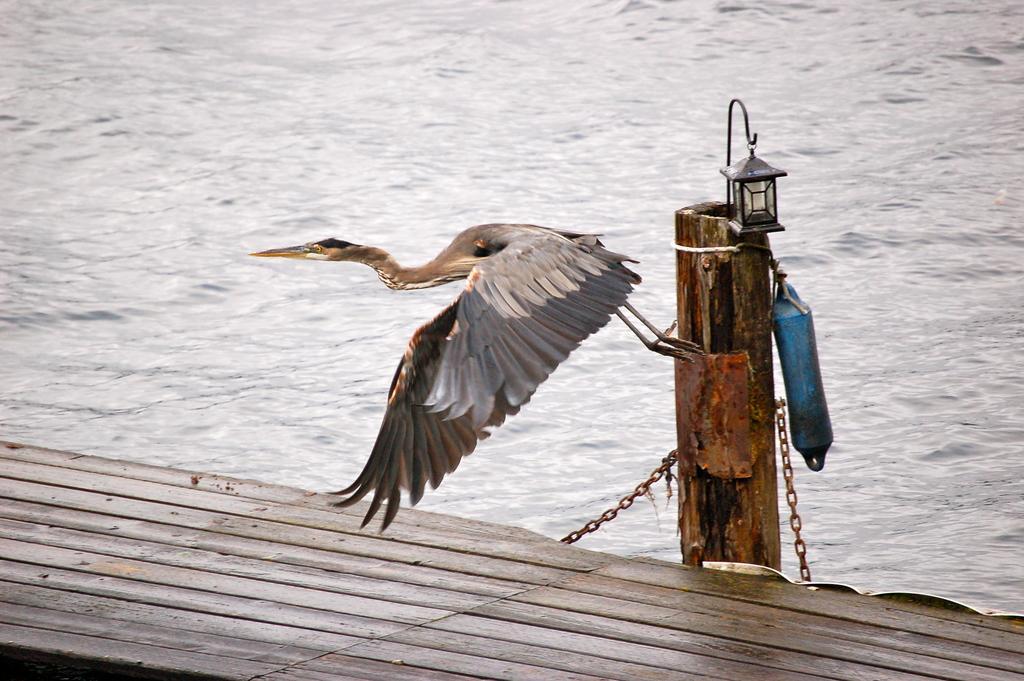Could you give a brief overview of what you see in this image? At the bottom of the image we can see raft and pile, on the pole we can see some lights. Behind the pole we can see water. In the middle of the image a bird is flying. 